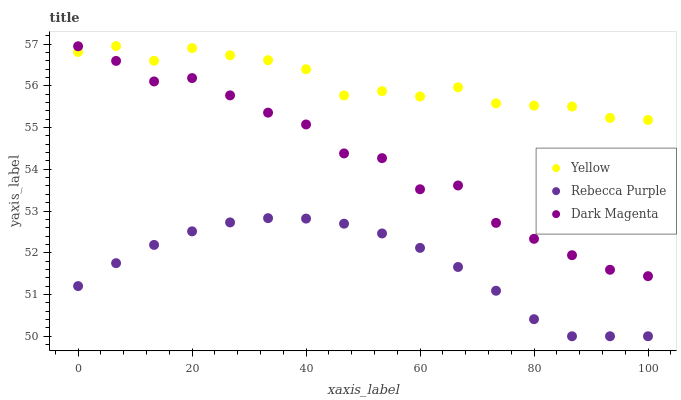Does Rebecca Purple have the minimum area under the curve?
Answer yes or no. Yes. Does Yellow have the maximum area under the curve?
Answer yes or no. Yes. Does Dark Magenta have the minimum area under the curve?
Answer yes or no. No. Does Dark Magenta have the maximum area under the curve?
Answer yes or no. No. Is Rebecca Purple the smoothest?
Answer yes or no. Yes. Is Dark Magenta the roughest?
Answer yes or no. Yes. Is Yellow the smoothest?
Answer yes or no. No. Is Yellow the roughest?
Answer yes or no. No. Does Rebecca Purple have the lowest value?
Answer yes or no. Yes. Does Dark Magenta have the lowest value?
Answer yes or no. No. Does Yellow have the highest value?
Answer yes or no. Yes. Does Dark Magenta have the highest value?
Answer yes or no. No. Is Rebecca Purple less than Dark Magenta?
Answer yes or no. Yes. Is Dark Magenta greater than Rebecca Purple?
Answer yes or no. Yes. Does Dark Magenta intersect Yellow?
Answer yes or no. Yes. Is Dark Magenta less than Yellow?
Answer yes or no. No. Is Dark Magenta greater than Yellow?
Answer yes or no. No. Does Rebecca Purple intersect Dark Magenta?
Answer yes or no. No. 